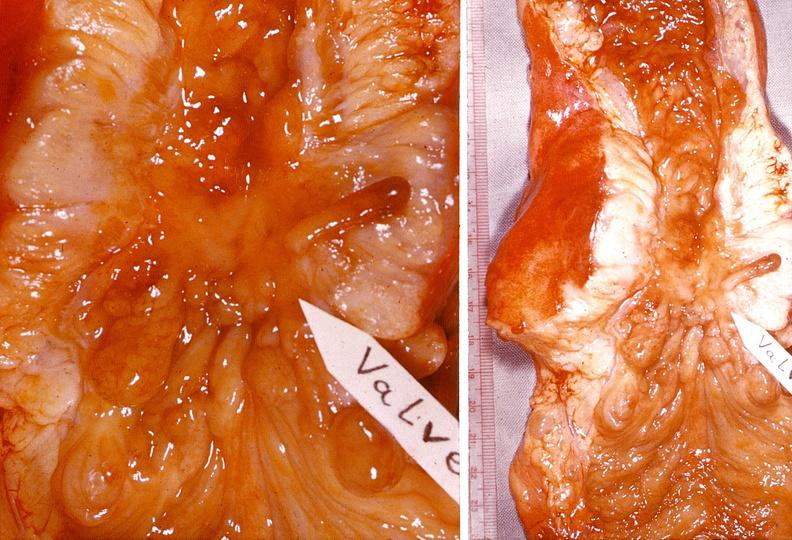what is present?
Answer the question using a single word or phrase. Gastrointestinal 